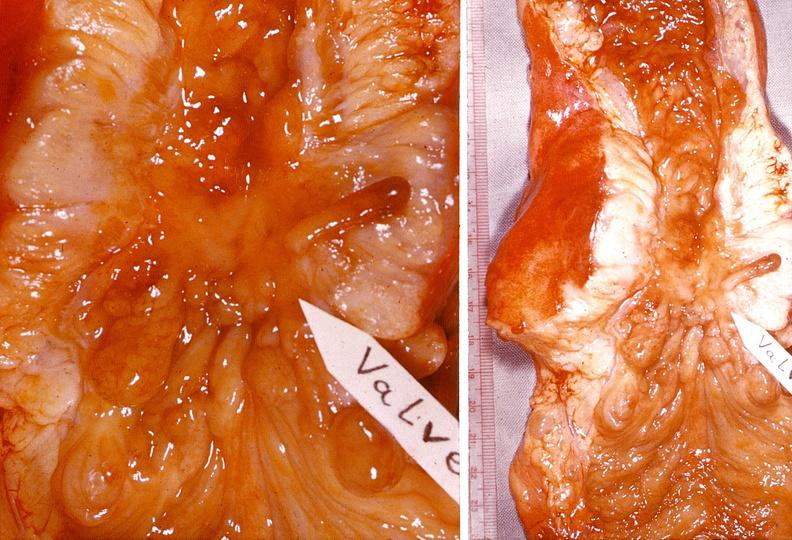what is present?
Answer the question using a single word or phrase. Gastrointestinal 